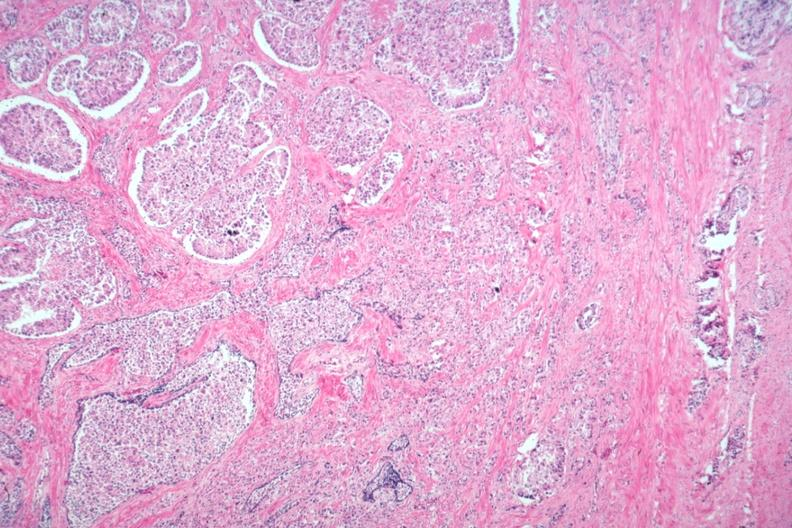what does this image show?
Answer the question using a single word or phrase. Typical lesion 